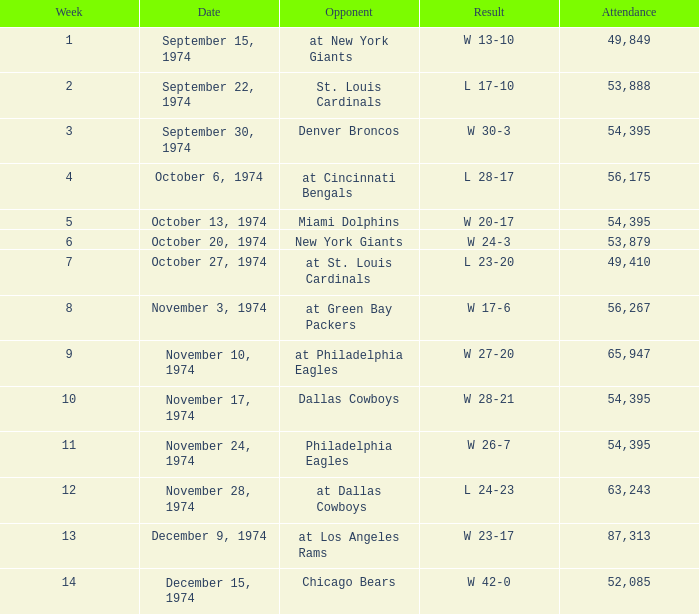What is the week of the game played on November 28, 1974? 12.0. 